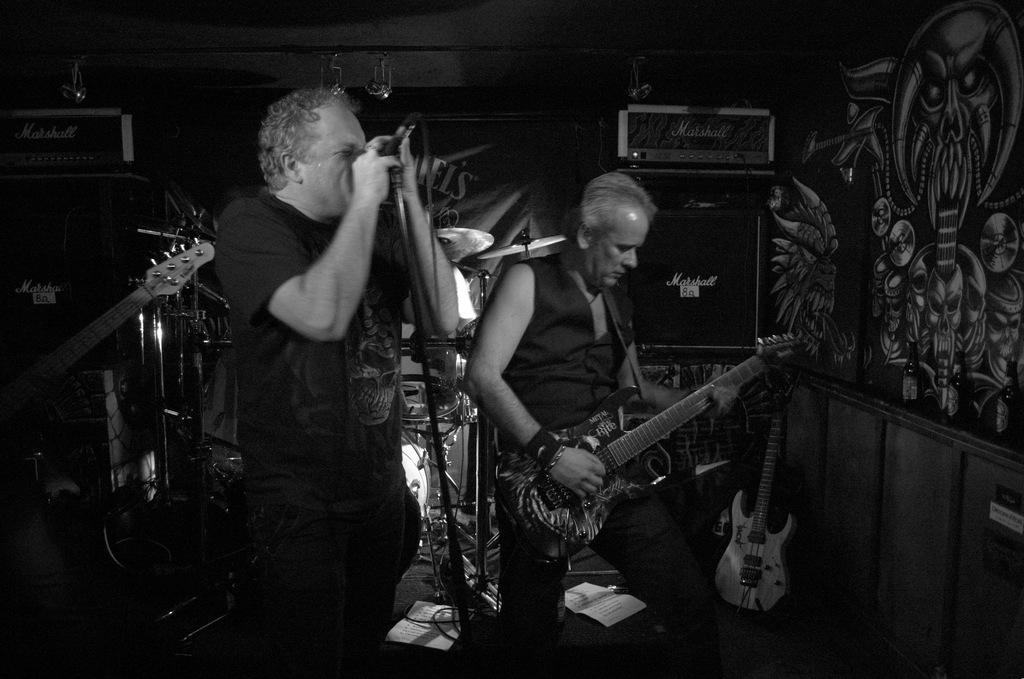How many people are in the image? There are two people in the image. What are the people in the image doing? Both people are playing a musical instrument. What type of cannon is being used by the people in the image? There is no cannon present in the image; both people are playing musical instruments. What is the title of the song being played by the people in the image? The image does not provide information about the title of the song being played. 